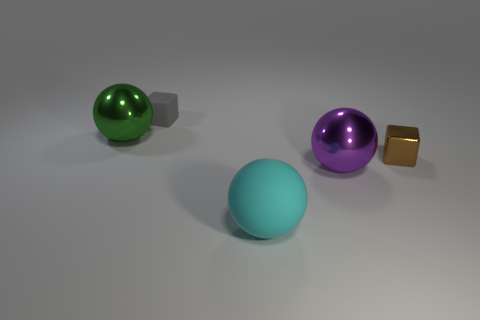What number of spheres are either purple shiny things or small things?
Keep it short and to the point. 1. The thing that is both in front of the gray block and behind the brown object has what shape?
Your answer should be compact. Sphere. What is the color of the small thing behind the tiny thing that is in front of the tiny thing that is on the left side of the small brown object?
Ensure brevity in your answer.  Gray. Are there fewer brown objects that are on the right side of the small brown shiny cube than purple cubes?
Offer a terse response. No. There is a small object behind the brown thing; is its shape the same as the large metallic object on the left side of the big cyan matte object?
Make the answer very short. No. How many objects are either metal objects that are left of the big cyan matte object or cubes?
Your answer should be compact. 3. Is there a cyan matte sphere that is behind the big shiny thing that is on the left side of the small thing that is on the left side of the metallic cube?
Your answer should be compact. No. Are there fewer gray cubes in front of the green sphere than large metal spheres that are right of the large cyan matte thing?
Give a very brief answer. Yes. What color is the sphere that is made of the same material as the green object?
Provide a short and direct response. Purple. There is a metallic thing that is left of the sphere that is in front of the purple metal ball; what is its color?
Your answer should be very brief. Green. 